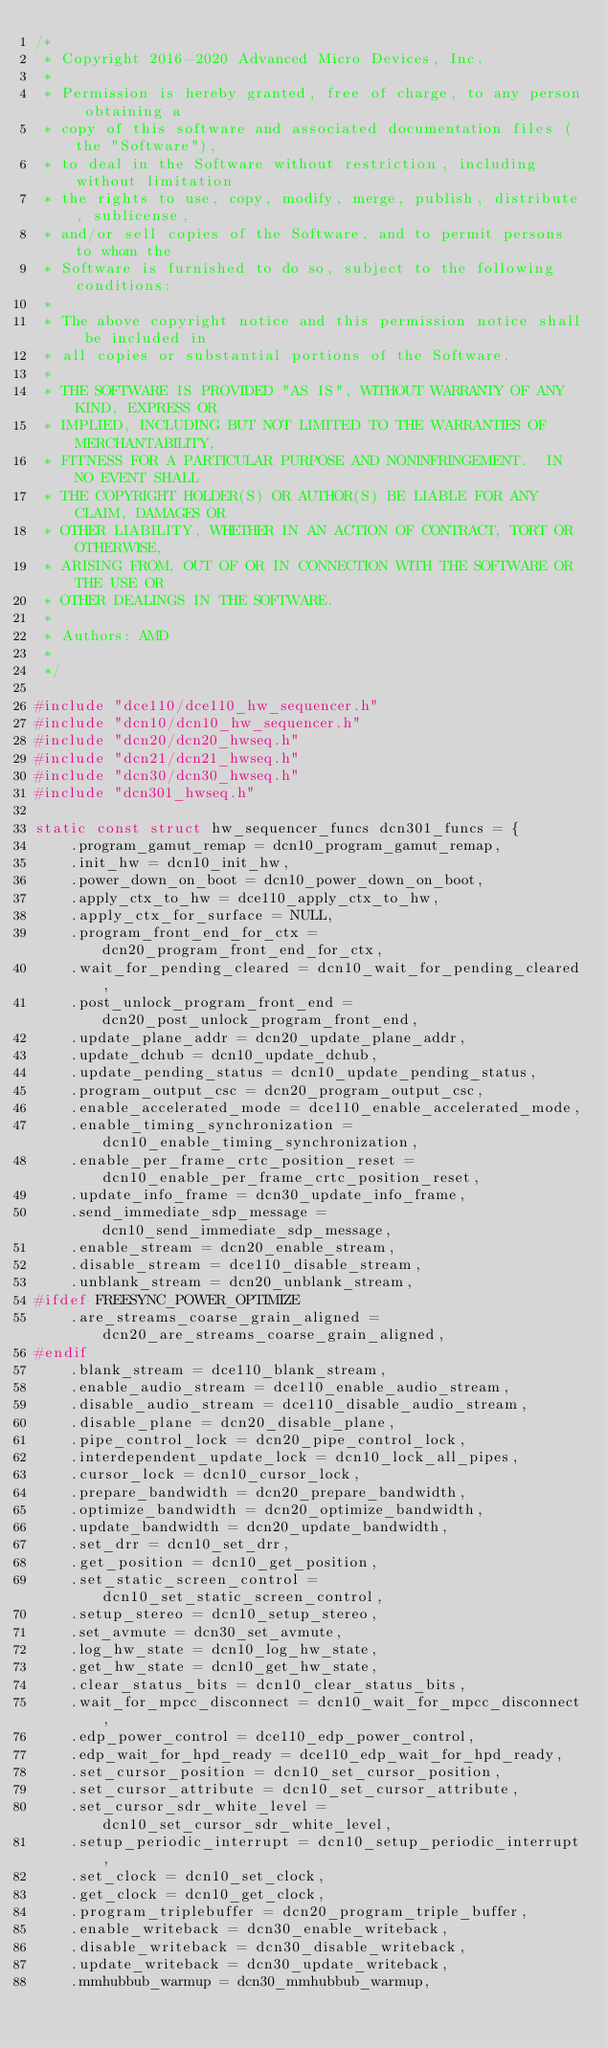<code> <loc_0><loc_0><loc_500><loc_500><_C_>/*
 * Copyright 2016-2020 Advanced Micro Devices, Inc.
 *
 * Permission is hereby granted, free of charge, to any person obtaining a
 * copy of this software and associated documentation files (the "Software"),
 * to deal in the Software without restriction, including without limitation
 * the rights to use, copy, modify, merge, publish, distribute, sublicense,
 * and/or sell copies of the Software, and to permit persons to whom the
 * Software is furnished to do so, subject to the following conditions:
 *
 * The above copyright notice and this permission notice shall be included in
 * all copies or substantial portions of the Software.
 *
 * THE SOFTWARE IS PROVIDED "AS IS", WITHOUT WARRANTY OF ANY KIND, EXPRESS OR
 * IMPLIED, INCLUDING BUT NOT LIMITED TO THE WARRANTIES OF MERCHANTABILITY,
 * FITNESS FOR A PARTICULAR PURPOSE AND NONINFRINGEMENT.  IN NO EVENT SHALL
 * THE COPYRIGHT HOLDER(S) OR AUTHOR(S) BE LIABLE FOR ANY CLAIM, DAMAGES OR
 * OTHER LIABILITY, WHETHER IN AN ACTION OF CONTRACT, TORT OR OTHERWISE,
 * ARISING FROM, OUT OF OR IN CONNECTION WITH THE SOFTWARE OR THE USE OR
 * OTHER DEALINGS IN THE SOFTWARE.
 *
 * Authors: AMD
 *
 */

#include "dce110/dce110_hw_sequencer.h"
#include "dcn10/dcn10_hw_sequencer.h"
#include "dcn20/dcn20_hwseq.h"
#include "dcn21/dcn21_hwseq.h"
#include "dcn30/dcn30_hwseq.h"
#include "dcn301_hwseq.h"

static const struct hw_sequencer_funcs dcn301_funcs = {
	.program_gamut_remap = dcn10_program_gamut_remap,
	.init_hw = dcn10_init_hw,
	.power_down_on_boot = dcn10_power_down_on_boot,
	.apply_ctx_to_hw = dce110_apply_ctx_to_hw,
	.apply_ctx_for_surface = NULL,
	.program_front_end_for_ctx = dcn20_program_front_end_for_ctx,
	.wait_for_pending_cleared = dcn10_wait_for_pending_cleared,
	.post_unlock_program_front_end = dcn20_post_unlock_program_front_end,
	.update_plane_addr = dcn20_update_plane_addr,
	.update_dchub = dcn10_update_dchub,
	.update_pending_status = dcn10_update_pending_status,
	.program_output_csc = dcn20_program_output_csc,
	.enable_accelerated_mode = dce110_enable_accelerated_mode,
	.enable_timing_synchronization = dcn10_enable_timing_synchronization,
	.enable_per_frame_crtc_position_reset = dcn10_enable_per_frame_crtc_position_reset,
	.update_info_frame = dcn30_update_info_frame,
	.send_immediate_sdp_message = dcn10_send_immediate_sdp_message,
	.enable_stream = dcn20_enable_stream,
	.disable_stream = dce110_disable_stream,
	.unblank_stream = dcn20_unblank_stream,
#ifdef FREESYNC_POWER_OPTIMIZE
	.are_streams_coarse_grain_aligned = dcn20_are_streams_coarse_grain_aligned,
#endif
	.blank_stream = dce110_blank_stream,
	.enable_audio_stream = dce110_enable_audio_stream,
	.disable_audio_stream = dce110_disable_audio_stream,
	.disable_plane = dcn20_disable_plane,
	.pipe_control_lock = dcn20_pipe_control_lock,
	.interdependent_update_lock = dcn10_lock_all_pipes,
	.cursor_lock = dcn10_cursor_lock,
	.prepare_bandwidth = dcn20_prepare_bandwidth,
	.optimize_bandwidth = dcn20_optimize_bandwidth,
	.update_bandwidth = dcn20_update_bandwidth,
	.set_drr = dcn10_set_drr,
	.get_position = dcn10_get_position,
	.set_static_screen_control = dcn10_set_static_screen_control,
	.setup_stereo = dcn10_setup_stereo,
	.set_avmute = dcn30_set_avmute,
	.log_hw_state = dcn10_log_hw_state,
	.get_hw_state = dcn10_get_hw_state,
	.clear_status_bits = dcn10_clear_status_bits,
	.wait_for_mpcc_disconnect = dcn10_wait_for_mpcc_disconnect,
	.edp_power_control = dce110_edp_power_control,
	.edp_wait_for_hpd_ready = dce110_edp_wait_for_hpd_ready,
	.set_cursor_position = dcn10_set_cursor_position,
	.set_cursor_attribute = dcn10_set_cursor_attribute,
	.set_cursor_sdr_white_level = dcn10_set_cursor_sdr_white_level,
	.setup_periodic_interrupt = dcn10_setup_periodic_interrupt,
	.set_clock = dcn10_set_clock,
	.get_clock = dcn10_get_clock,
	.program_triplebuffer = dcn20_program_triple_buffer,
	.enable_writeback = dcn30_enable_writeback,
	.disable_writeback = dcn30_disable_writeback,
	.update_writeback = dcn30_update_writeback,
	.mmhubbub_warmup = dcn30_mmhubbub_warmup,</code> 